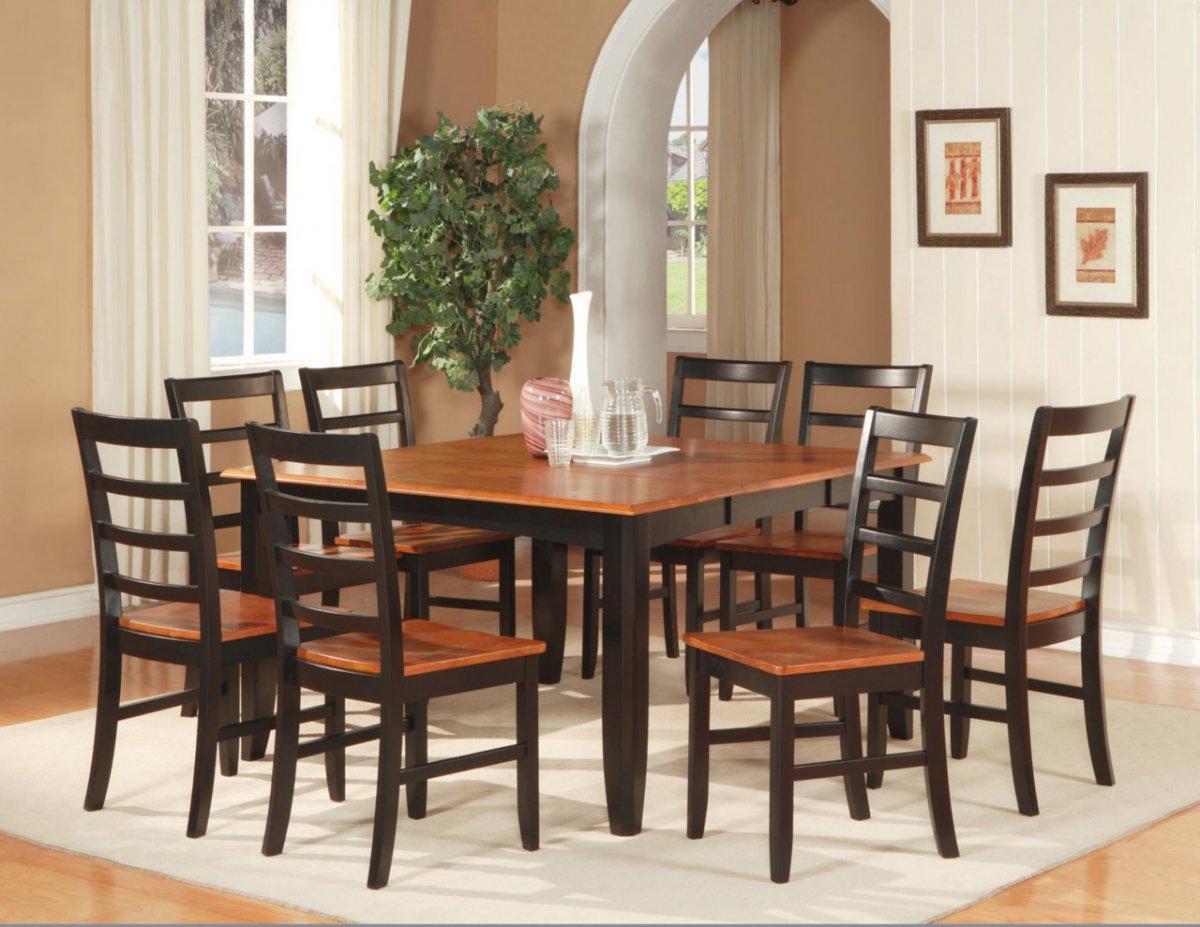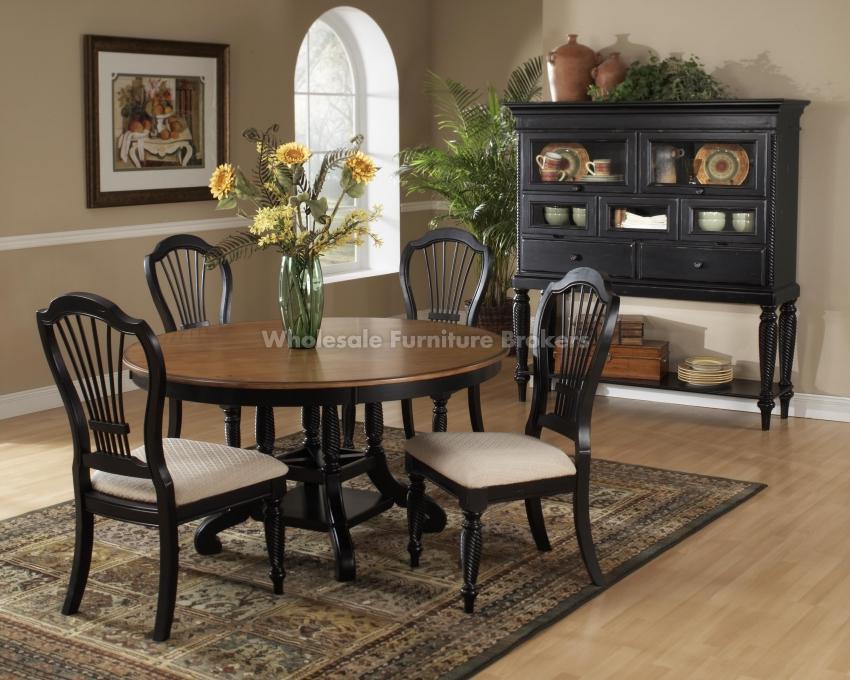The first image is the image on the left, the second image is the image on the right. Considering the images on both sides, is "There are three windows on the left wall in the image on the left." valid? Answer yes or no. No. 